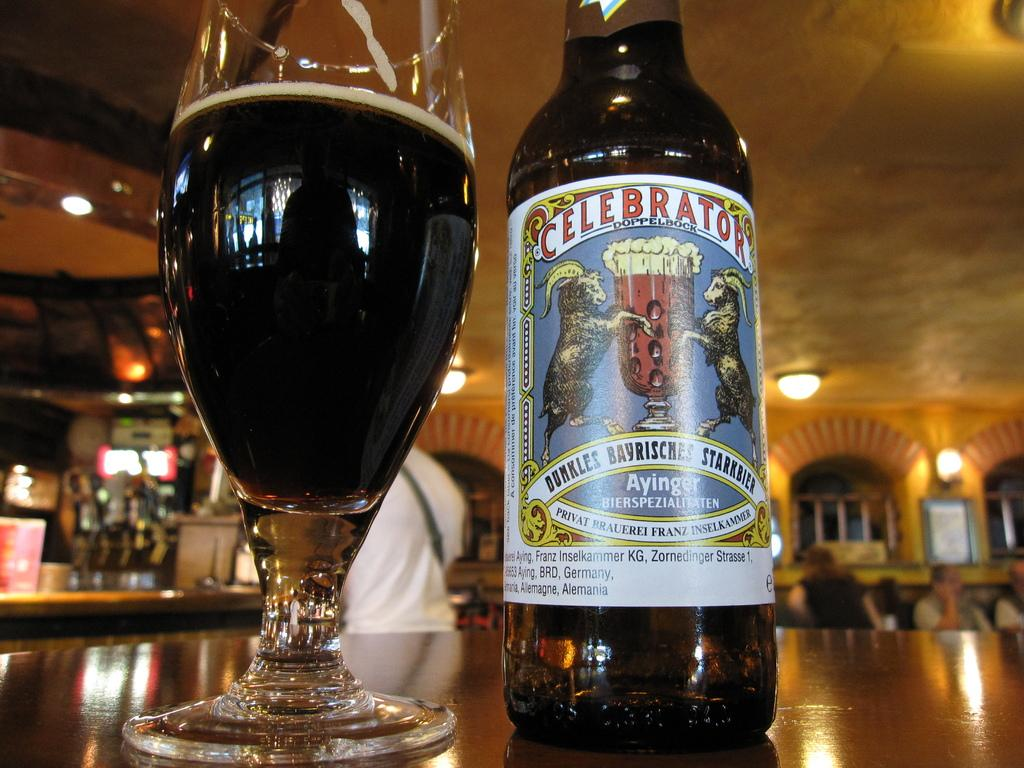<image>
Describe the image concisely. A bottle reading "Celebrator Doppelbock" next to a glass filled with the bottle's contents. 